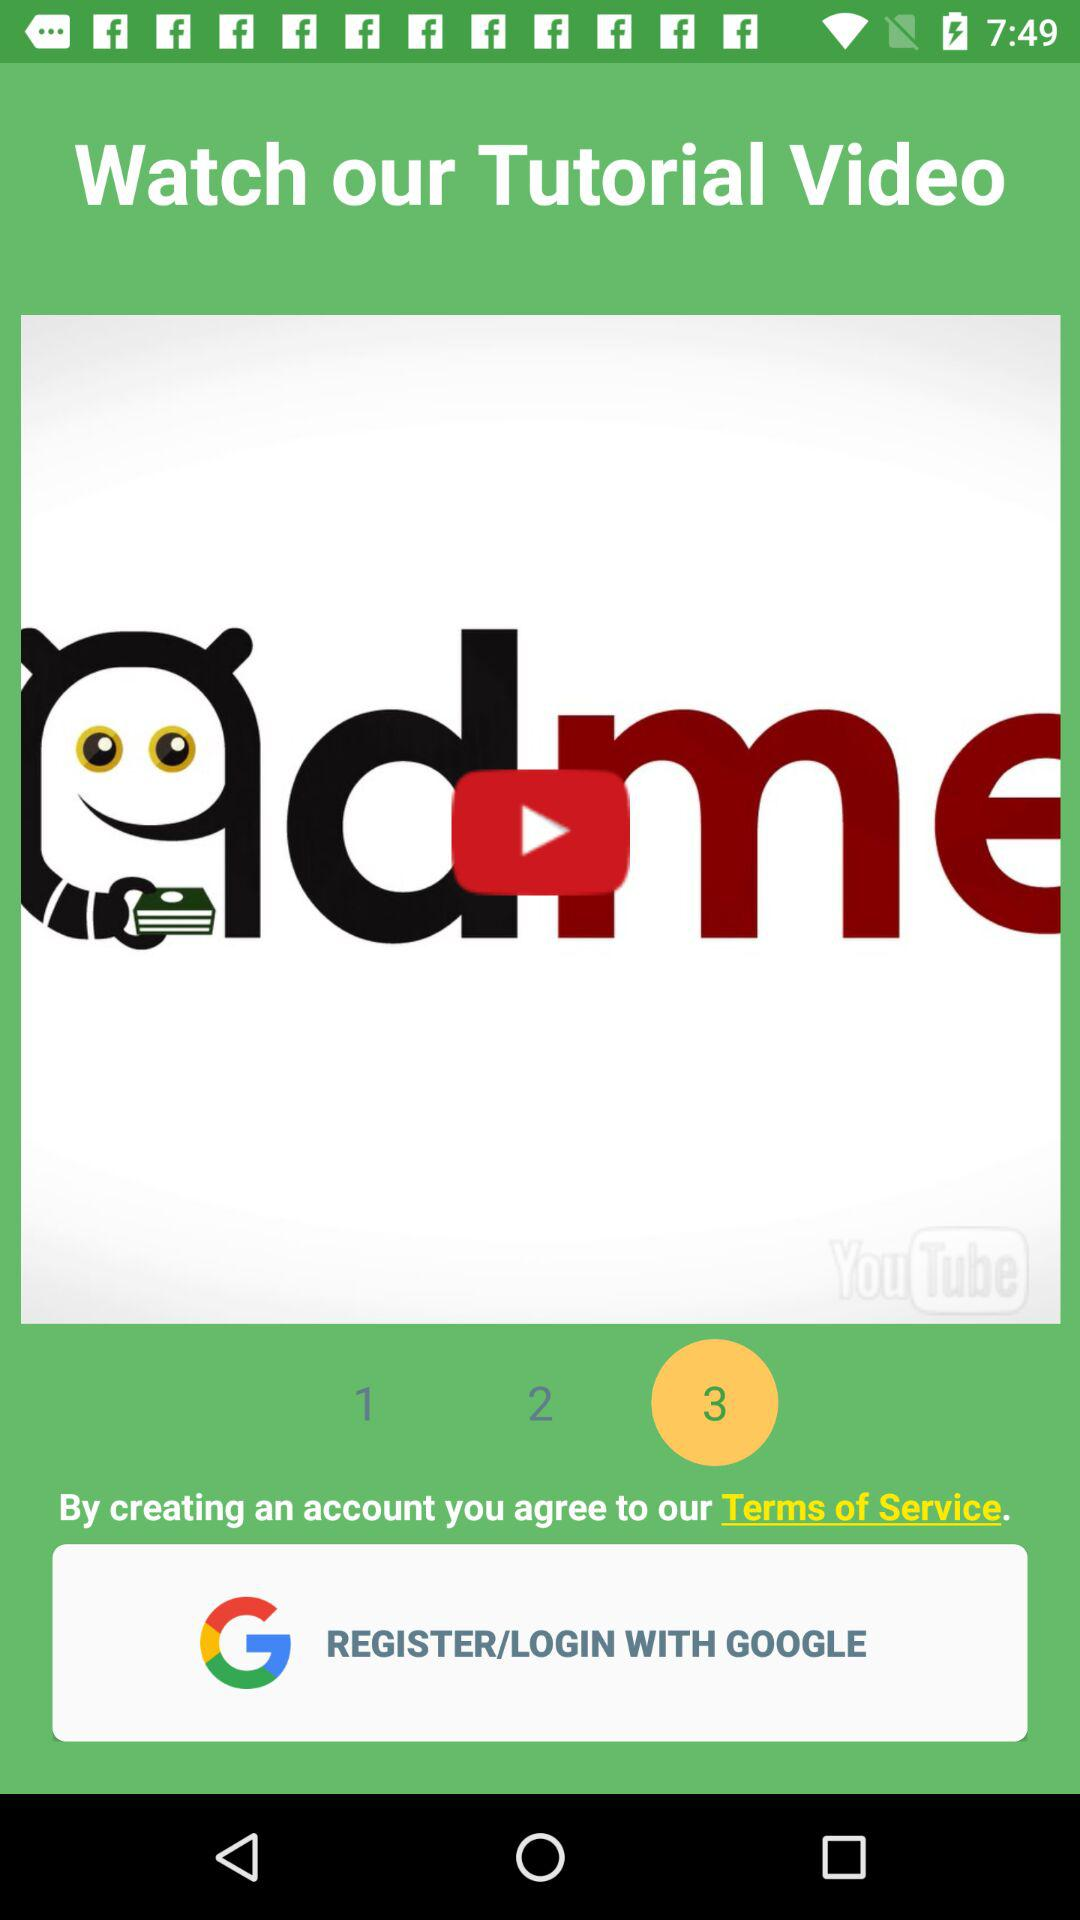Has the user agreed to the terms of service?
When the provided information is insufficient, respond with <no answer>. <no answer> 